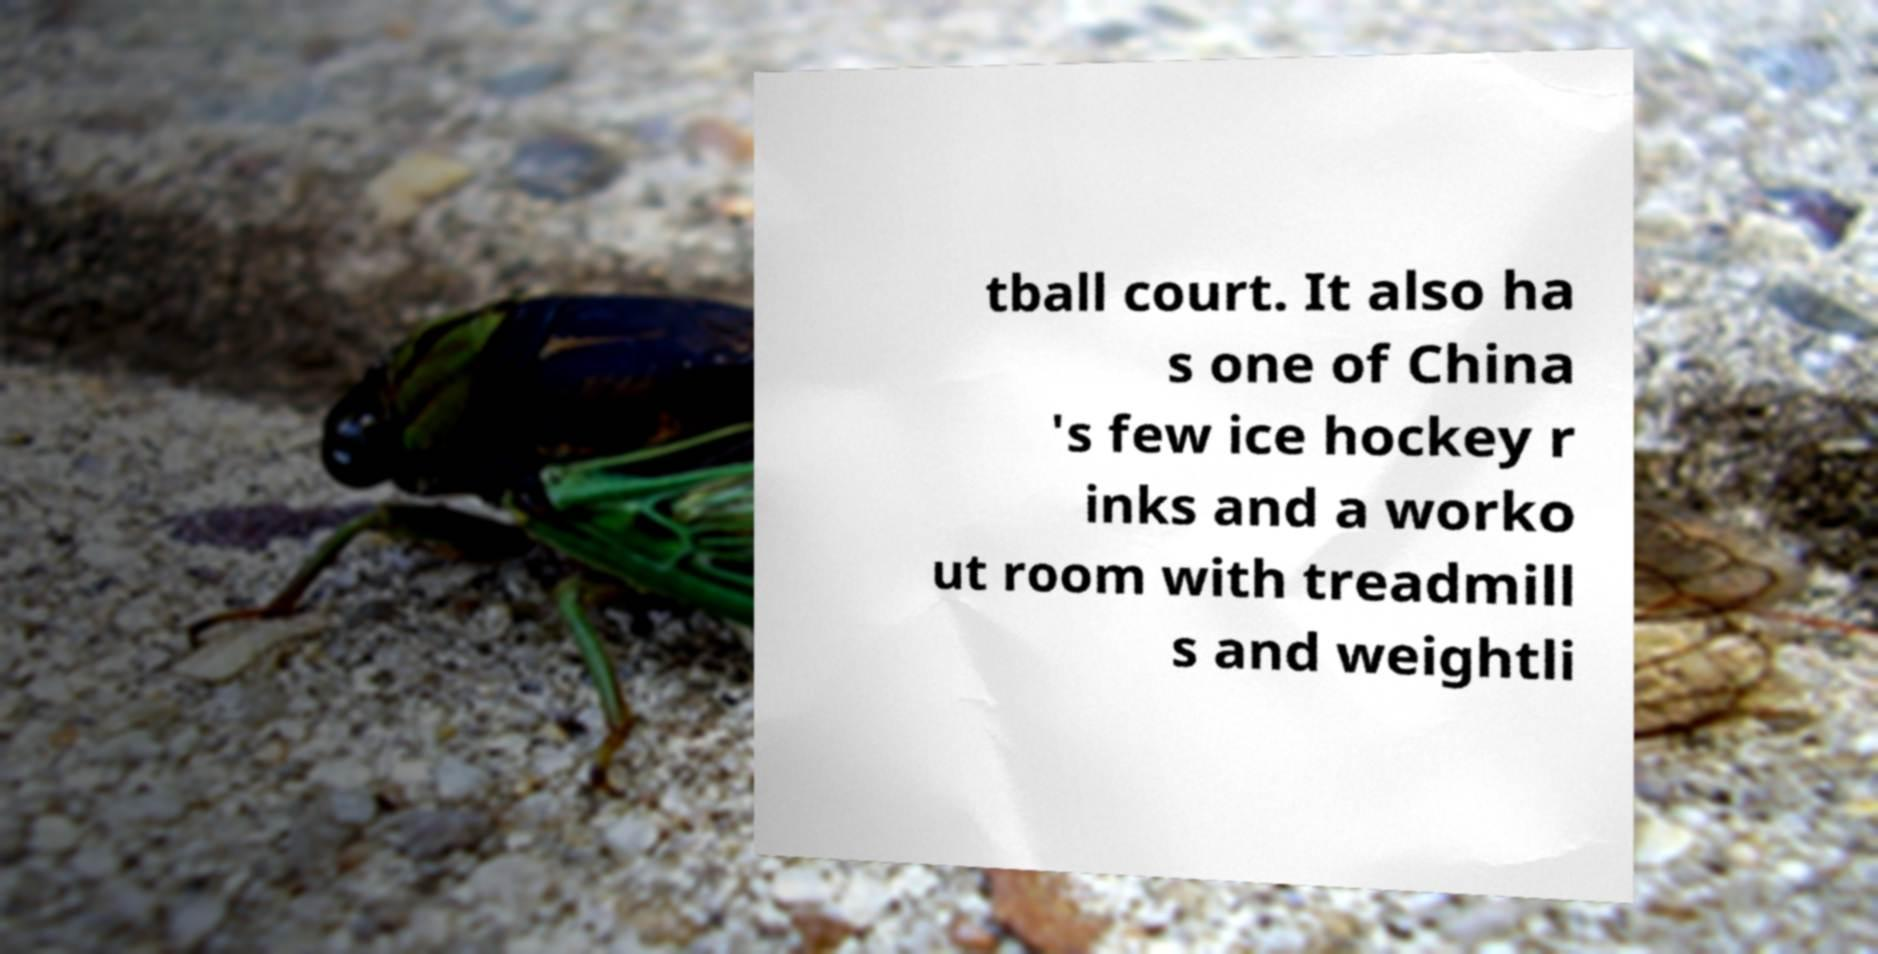I need the written content from this picture converted into text. Can you do that? tball court. It also ha s one of China 's few ice hockey r inks and a worko ut room with treadmill s and weightli 